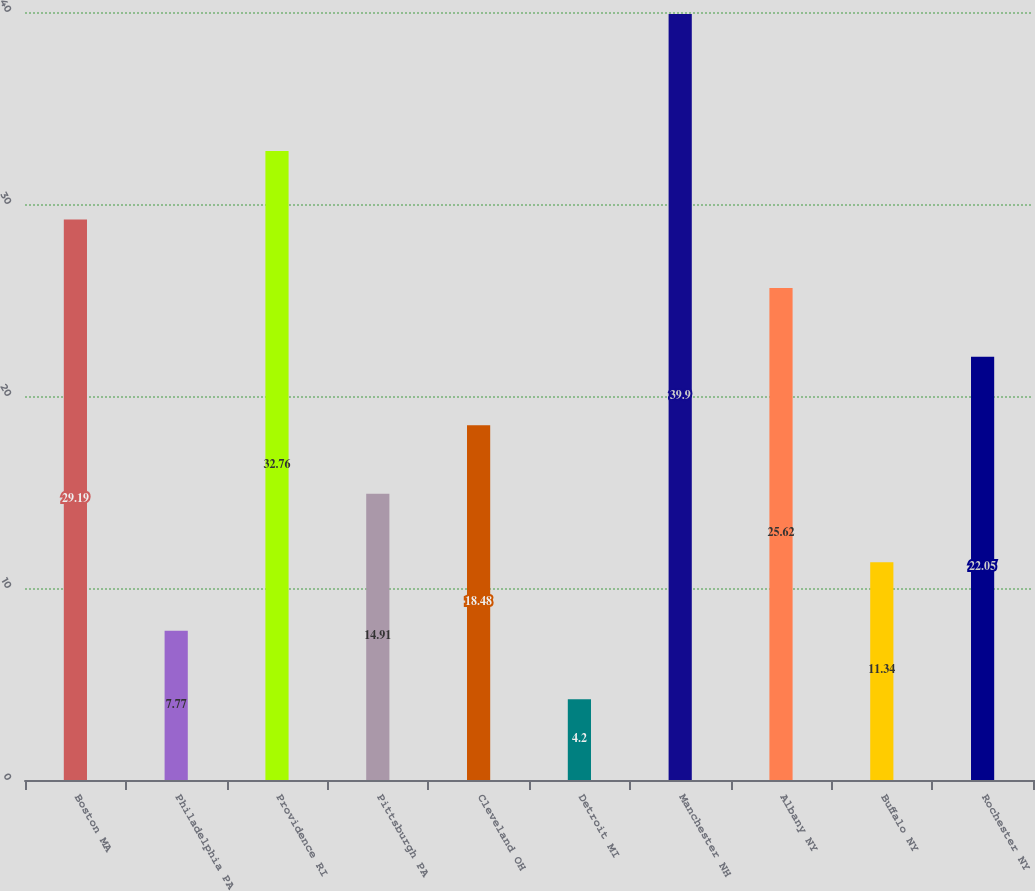<chart> <loc_0><loc_0><loc_500><loc_500><bar_chart><fcel>Boston MA<fcel>Philadelphia PA<fcel>Providence RI<fcel>Pittsburgh PA<fcel>Cleveland OH<fcel>Detroit MI<fcel>Manchester NH<fcel>Albany NY<fcel>Buffalo NY<fcel>Rochester NY<nl><fcel>29.19<fcel>7.77<fcel>32.76<fcel>14.91<fcel>18.48<fcel>4.2<fcel>39.9<fcel>25.62<fcel>11.34<fcel>22.05<nl></chart> 